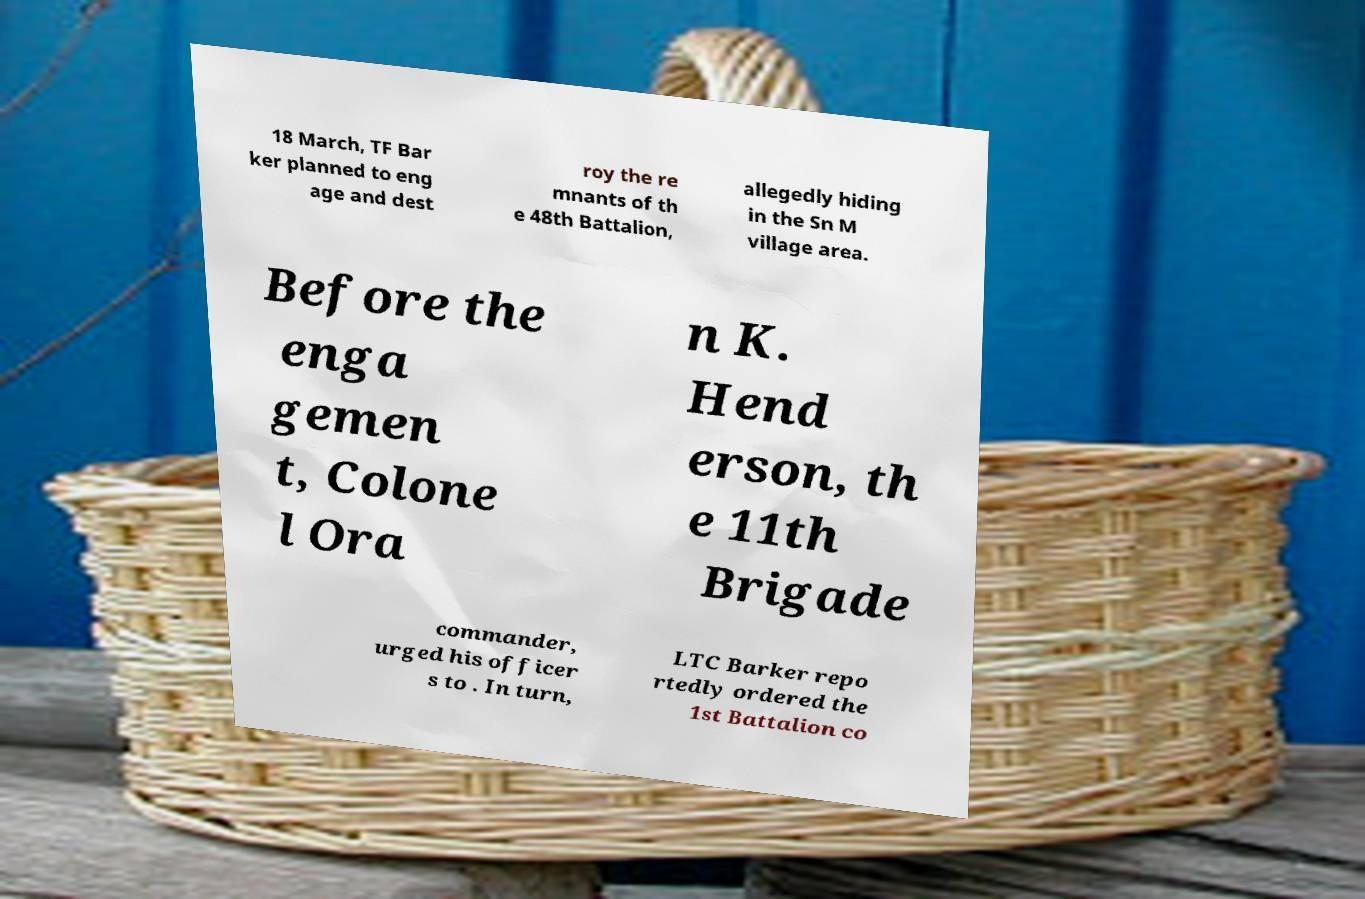There's text embedded in this image that I need extracted. Can you transcribe it verbatim? 18 March, TF Bar ker planned to eng age and dest roy the re mnants of th e 48th Battalion, allegedly hiding in the Sn M village area. Before the enga gemen t, Colone l Ora n K. Hend erson, th e 11th Brigade commander, urged his officer s to . In turn, LTC Barker repo rtedly ordered the 1st Battalion co 